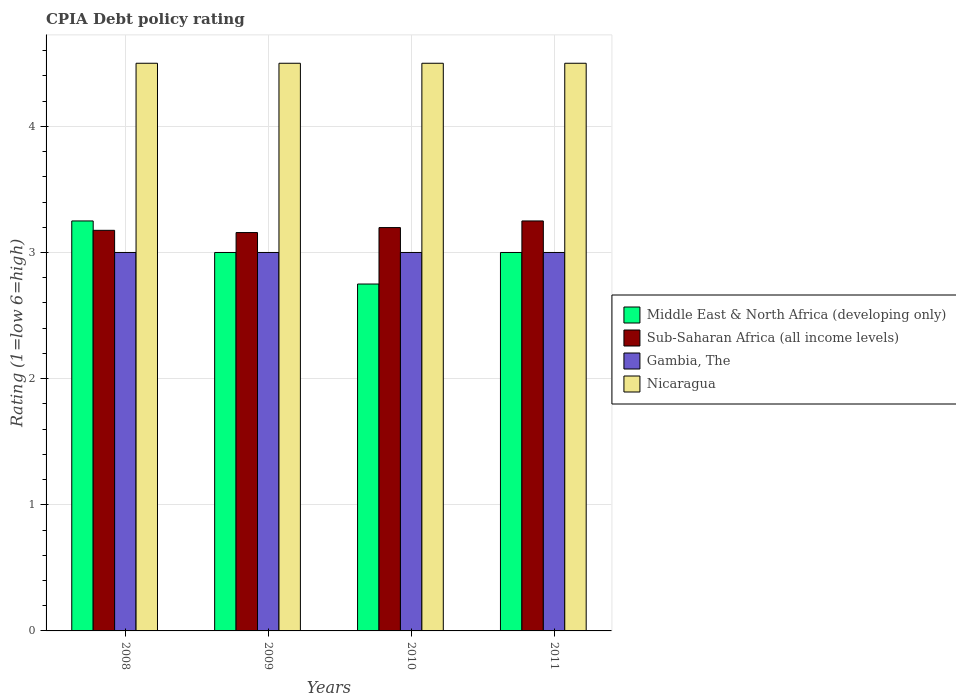Are the number of bars per tick equal to the number of legend labels?
Your answer should be compact. Yes. Are the number of bars on each tick of the X-axis equal?
Give a very brief answer. Yes. How many bars are there on the 1st tick from the right?
Your answer should be very brief. 4. What is the CPIA rating in Gambia, The in 2009?
Give a very brief answer. 3. Across all years, what is the maximum CPIA rating in Gambia, The?
Provide a short and direct response. 3. Across all years, what is the minimum CPIA rating in Middle East & North Africa (developing only)?
Offer a very short reply. 2.75. In which year was the CPIA rating in Gambia, The minimum?
Keep it short and to the point. 2008. What is the difference between the CPIA rating in Sub-Saharan Africa (all income levels) in 2010 and that in 2011?
Give a very brief answer. -0.05. What is the difference between the CPIA rating in Sub-Saharan Africa (all income levels) in 2011 and the CPIA rating in Gambia, The in 2010?
Your answer should be very brief. 0.25. What is the average CPIA rating in Nicaragua per year?
Provide a short and direct response. 4.5. In the year 2011, what is the difference between the CPIA rating in Middle East & North Africa (developing only) and CPIA rating in Nicaragua?
Provide a succinct answer. -1.5. What is the difference between the highest and the lowest CPIA rating in Sub-Saharan Africa (all income levels)?
Your response must be concise. 0.09. In how many years, is the CPIA rating in Nicaragua greater than the average CPIA rating in Nicaragua taken over all years?
Your answer should be very brief. 0. What does the 2nd bar from the left in 2010 represents?
Provide a short and direct response. Sub-Saharan Africa (all income levels). What does the 4th bar from the right in 2010 represents?
Your response must be concise. Middle East & North Africa (developing only). Is it the case that in every year, the sum of the CPIA rating in Middle East & North Africa (developing only) and CPIA rating in Nicaragua is greater than the CPIA rating in Sub-Saharan Africa (all income levels)?
Your answer should be compact. Yes. How many bars are there?
Provide a succinct answer. 16. What is the difference between two consecutive major ticks on the Y-axis?
Provide a succinct answer. 1. Where does the legend appear in the graph?
Make the answer very short. Center right. How are the legend labels stacked?
Your response must be concise. Vertical. What is the title of the graph?
Provide a short and direct response. CPIA Debt policy rating. What is the label or title of the X-axis?
Your answer should be compact. Years. What is the Rating (1=low 6=high) in Sub-Saharan Africa (all income levels) in 2008?
Provide a short and direct response. 3.18. What is the Rating (1=low 6=high) of Sub-Saharan Africa (all income levels) in 2009?
Your response must be concise. 3.16. What is the Rating (1=low 6=high) of Gambia, The in 2009?
Your answer should be very brief. 3. What is the Rating (1=low 6=high) in Nicaragua in 2009?
Ensure brevity in your answer.  4.5. What is the Rating (1=low 6=high) in Middle East & North Africa (developing only) in 2010?
Keep it short and to the point. 2.75. What is the Rating (1=low 6=high) of Sub-Saharan Africa (all income levels) in 2010?
Provide a short and direct response. 3.2. What is the Rating (1=low 6=high) of Middle East & North Africa (developing only) in 2011?
Provide a succinct answer. 3. What is the Rating (1=low 6=high) of Sub-Saharan Africa (all income levels) in 2011?
Your answer should be compact. 3.25. What is the Rating (1=low 6=high) in Nicaragua in 2011?
Your response must be concise. 4.5. Across all years, what is the maximum Rating (1=low 6=high) in Middle East & North Africa (developing only)?
Your response must be concise. 3.25. Across all years, what is the minimum Rating (1=low 6=high) of Middle East & North Africa (developing only)?
Your answer should be compact. 2.75. Across all years, what is the minimum Rating (1=low 6=high) of Sub-Saharan Africa (all income levels)?
Your response must be concise. 3.16. Across all years, what is the minimum Rating (1=low 6=high) of Gambia, The?
Make the answer very short. 3. Across all years, what is the minimum Rating (1=low 6=high) of Nicaragua?
Your answer should be very brief. 4.5. What is the total Rating (1=low 6=high) in Middle East & North Africa (developing only) in the graph?
Provide a short and direct response. 12. What is the total Rating (1=low 6=high) of Sub-Saharan Africa (all income levels) in the graph?
Give a very brief answer. 12.78. What is the total Rating (1=low 6=high) in Gambia, The in the graph?
Provide a short and direct response. 12. What is the total Rating (1=low 6=high) in Nicaragua in the graph?
Ensure brevity in your answer.  18. What is the difference between the Rating (1=low 6=high) in Sub-Saharan Africa (all income levels) in 2008 and that in 2009?
Your answer should be compact. 0.02. What is the difference between the Rating (1=low 6=high) of Gambia, The in 2008 and that in 2009?
Ensure brevity in your answer.  0. What is the difference between the Rating (1=low 6=high) in Nicaragua in 2008 and that in 2009?
Make the answer very short. 0. What is the difference between the Rating (1=low 6=high) in Middle East & North Africa (developing only) in 2008 and that in 2010?
Your answer should be very brief. 0.5. What is the difference between the Rating (1=low 6=high) of Sub-Saharan Africa (all income levels) in 2008 and that in 2010?
Offer a terse response. -0.02. What is the difference between the Rating (1=low 6=high) of Gambia, The in 2008 and that in 2010?
Your response must be concise. 0. What is the difference between the Rating (1=low 6=high) in Nicaragua in 2008 and that in 2010?
Keep it short and to the point. 0. What is the difference between the Rating (1=low 6=high) of Middle East & North Africa (developing only) in 2008 and that in 2011?
Ensure brevity in your answer.  0.25. What is the difference between the Rating (1=low 6=high) of Sub-Saharan Africa (all income levels) in 2008 and that in 2011?
Give a very brief answer. -0.07. What is the difference between the Rating (1=low 6=high) in Gambia, The in 2008 and that in 2011?
Offer a terse response. 0. What is the difference between the Rating (1=low 6=high) in Sub-Saharan Africa (all income levels) in 2009 and that in 2010?
Provide a succinct answer. -0.04. What is the difference between the Rating (1=low 6=high) in Gambia, The in 2009 and that in 2010?
Your answer should be compact. 0. What is the difference between the Rating (1=low 6=high) of Nicaragua in 2009 and that in 2010?
Give a very brief answer. 0. What is the difference between the Rating (1=low 6=high) in Middle East & North Africa (developing only) in 2009 and that in 2011?
Provide a succinct answer. 0. What is the difference between the Rating (1=low 6=high) of Sub-Saharan Africa (all income levels) in 2009 and that in 2011?
Provide a succinct answer. -0.09. What is the difference between the Rating (1=low 6=high) of Gambia, The in 2009 and that in 2011?
Provide a short and direct response. 0. What is the difference between the Rating (1=low 6=high) of Middle East & North Africa (developing only) in 2010 and that in 2011?
Make the answer very short. -0.25. What is the difference between the Rating (1=low 6=high) in Sub-Saharan Africa (all income levels) in 2010 and that in 2011?
Offer a very short reply. -0.05. What is the difference between the Rating (1=low 6=high) in Gambia, The in 2010 and that in 2011?
Offer a very short reply. 0. What is the difference between the Rating (1=low 6=high) of Middle East & North Africa (developing only) in 2008 and the Rating (1=low 6=high) of Sub-Saharan Africa (all income levels) in 2009?
Offer a terse response. 0.09. What is the difference between the Rating (1=low 6=high) of Middle East & North Africa (developing only) in 2008 and the Rating (1=low 6=high) of Gambia, The in 2009?
Your response must be concise. 0.25. What is the difference between the Rating (1=low 6=high) in Middle East & North Africa (developing only) in 2008 and the Rating (1=low 6=high) in Nicaragua in 2009?
Keep it short and to the point. -1.25. What is the difference between the Rating (1=low 6=high) in Sub-Saharan Africa (all income levels) in 2008 and the Rating (1=low 6=high) in Gambia, The in 2009?
Offer a very short reply. 0.18. What is the difference between the Rating (1=low 6=high) of Sub-Saharan Africa (all income levels) in 2008 and the Rating (1=low 6=high) of Nicaragua in 2009?
Make the answer very short. -1.32. What is the difference between the Rating (1=low 6=high) of Gambia, The in 2008 and the Rating (1=low 6=high) of Nicaragua in 2009?
Your answer should be compact. -1.5. What is the difference between the Rating (1=low 6=high) in Middle East & North Africa (developing only) in 2008 and the Rating (1=low 6=high) in Sub-Saharan Africa (all income levels) in 2010?
Offer a very short reply. 0.05. What is the difference between the Rating (1=low 6=high) in Middle East & North Africa (developing only) in 2008 and the Rating (1=low 6=high) in Nicaragua in 2010?
Offer a very short reply. -1.25. What is the difference between the Rating (1=low 6=high) of Sub-Saharan Africa (all income levels) in 2008 and the Rating (1=low 6=high) of Gambia, The in 2010?
Provide a succinct answer. 0.18. What is the difference between the Rating (1=low 6=high) of Sub-Saharan Africa (all income levels) in 2008 and the Rating (1=low 6=high) of Nicaragua in 2010?
Offer a very short reply. -1.32. What is the difference between the Rating (1=low 6=high) of Gambia, The in 2008 and the Rating (1=low 6=high) of Nicaragua in 2010?
Provide a short and direct response. -1.5. What is the difference between the Rating (1=low 6=high) in Middle East & North Africa (developing only) in 2008 and the Rating (1=low 6=high) in Sub-Saharan Africa (all income levels) in 2011?
Give a very brief answer. 0. What is the difference between the Rating (1=low 6=high) of Middle East & North Africa (developing only) in 2008 and the Rating (1=low 6=high) of Gambia, The in 2011?
Offer a very short reply. 0.25. What is the difference between the Rating (1=low 6=high) of Middle East & North Africa (developing only) in 2008 and the Rating (1=low 6=high) of Nicaragua in 2011?
Your response must be concise. -1.25. What is the difference between the Rating (1=low 6=high) of Sub-Saharan Africa (all income levels) in 2008 and the Rating (1=low 6=high) of Gambia, The in 2011?
Provide a succinct answer. 0.18. What is the difference between the Rating (1=low 6=high) of Sub-Saharan Africa (all income levels) in 2008 and the Rating (1=low 6=high) of Nicaragua in 2011?
Give a very brief answer. -1.32. What is the difference between the Rating (1=low 6=high) of Middle East & North Africa (developing only) in 2009 and the Rating (1=low 6=high) of Sub-Saharan Africa (all income levels) in 2010?
Provide a succinct answer. -0.2. What is the difference between the Rating (1=low 6=high) in Sub-Saharan Africa (all income levels) in 2009 and the Rating (1=low 6=high) in Gambia, The in 2010?
Offer a very short reply. 0.16. What is the difference between the Rating (1=low 6=high) in Sub-Saharan Africa (all income levels) in 2009 and the Rating (1=low 6=high) in Nicaragua in 2010?
Make the answer very short. -1.34. What is the difference between the Rating (1=low 6=high) of Middle East & North Africa (developing only) in 2009 and the Rating (1=low 6=high) of Gambia, The in 2011?
Provide a succinct answer. 0. What is the difference between the Rating (1=low 6=high) of Middle East & North Africa (developing only) in 2009 and the Rating (1=low 6=high) of Nicaragua in 2011?
Make the answer very short. -1.5. What is the difference between the Rating (1=low 6=high) in Sub-Saharan Africa (all income levels) in 2009 and the Rating (1=low 6=high) in Gambia, The in 2011?
Ensure brevity in your answer.  0.16. What is the difference between the Rating (1=low 6=high) of Sub-Saharan Africa (all income levels) in 2009 and the Rating (1=low 6=high) of Nicaragua in 2011?
Offer a terse response. -1.34. What is the difference between the Rating (1=low 6=high) of Middle East & North Africa (developing only) in 2010 and the Rating (1=low 6=high) of Sub-Saharan Africa (all income levels) in 2011?
Ensure brevity in your answer.  -0.5. What is the difference between the Rating (1=low 6=high) of Middle East & North Africa (developing only) in 2010 and the Rating (1=low 6=high) of Gambia, The in 2011?
Your response must be concise. -0.25. What is the difference between the Rating (1=low 6=high) of Middle East & North Africa (developing only) in 2010 and the Rating (1=low 6=high) of Nicaragua in 2011?
Your answer should be compact. -1.75. What is the difference between the Rating (1=low 6=high) in Sub-Saharan Africa (all income levels) in 2010 and the Rating (1=low 6=high) in Gambia, The in 2011?
Keep it short and to the point. 0.2. What is the difference between the Rating (1=low 6=high) in Sub-Saharan Africa (all income levels) in 2010 and the Rating (1=low 6=high) in Nicaragua in 2011?
Your answer should be very brief. -1.3. What is the average Rating (1=low 6=high) of Sub-Saharan Africa (all income levels) per year?
Offer a very short reply. 3.2. What is the average Rating (1=low 6=high) in Gambia, The per year?
Provide a short and direct response. 3. What is the average Rating (1=low 6=high) in Nicaragua per year?
Offer a terse response. 4.5. In the year 2008, what is the difference between the Rating (1=low 6=high) of Middle East & North Africa (developing only) and Rating (1=low 6=high) of Sub-Saharan Africa (all income levels)?
Give a very brief answer. 0.07. In the year 2008, what is the difference between the Rating (1=low 6=high) in Middle East & North Africa (developing only) and Rating (1=low 6=high) in Gambia, The?
Provide a succinct answer. 0.25. In the year 2008, what is the difference between the Rating (1=low 6=high) in Middle East & North Africa (developing only) and Rating (1=low 6=high) in Nicaragua?
Give a very brief answer. -1.25. In the year 2008, what is the difference between the Rating (1=low 6=high) of Sub-Saharan Africa (all income levels) and Rating (1=low 6=high) of Gambia, The?
Your answer should be compact. 0.18. In the year 2008, what is the difference between the Rating (1=low 6=high) of Sub-Saharan Africa (all income levels) and Rating (1=low 6=high) of Nicaragua?
Provide a short and direct response. -1.32. In the year 2008, what is the difference between the Rating (1=low 6=high) of Gambia, The and Rating (1=low 6=high) of Nicaragua?
Your answer should be very brief. -1.5. In the year 2009, what is the difference between the Rating (1=low 6=high) of Middle East & North Africa (developing only) and Rating (1=low 6=high) of Sub-Saharan Africa (all income levels)?
Your response must be concise. -0.16. In the year 2009, what is the difference between the Rating (1=low 6=high) of Middle East & North Africa (developing only) and Rating (1=low 6=high) of Nicaragua?
Provide a succinct answer. -1.5. In the year 2009, what is the difference between the Rating (1=low 6=high) of Sub-Saharan Africa (all income levels) and Rating (1=low 6=high) of Gambia, The?
Make the answer very short. 0.16. In the year 2009, what is the difference between the Rating (1=low 6=high) of Sub-Saharan Africa (all income levels) and Rating (1=low 6=high) of Nicaragua?
Keep it short and to the point. -1.34. In the year 2009, what is the difference between the Rating (1=low 6=high) of Gambia, The and Rating (1=low 6=high) of Nicaragua?
Give a very brief answer. -1.5. In the year 2010, what is the difference between the Rating (1=low 6=high) in Middle East & North Africa (developing only) and Rating (1=low 6=high) in Sub-Saharan Africa (all income levels)?
Your response must be concise. -0.45. In the year 2010, what is the difference between the Rating (1=low 6=high) of Middle East & North Africa (developing only) and Rating (1=low 6=high) of Gambia, The?
Offer a terse response. -0.25. In the year 2010, what is the difference between the Rating (1=low 6=high) of Middle East & North Africa (developing only) and Rating (1=low 6=high) of Nicaragua?
Your response must be concise. -1.75. In the year 2010, what is the difference between the Rating (1=low 6=high) in Sub-Saharan Africa (all income levels) and Rating (1=low 6=high) in Gambia, The?
Make the answer very short. 0.2. In the year 2010, what is the difference between the Rating (1=low 6=high) in Sub-Saharan Africa (all income levels) and Rating (1=low 6=high) in Nicaragua?
Provide a succinct answer. -1.3. In the year 2011, what is the difference between the Rating (1=low 6=high) in Middle East & North Africa (developing only) and Rating (1=low 6=high) in Sub-Saharan Africa (all income levels)?
Your answer should be compact. -0.25. In the year 2011, what is the difference between the Rating (1=low 6=high) of Middle East & North Africa (developing only) and Rating (1=low 6=high) of Nicaragua?
Provide a short and direct response. -1.5. In the year 2011, what is the difference between the Rating (1=low 6=high) of Sub-Saharan Africa (all income levels) and Rating (1=low 6=high) of Nicaragua?
Offer a very short reply. -1.25. What is the ratio of the Rating (1=low 6=high) in Sub-Saharan Africa (all income levels) in 2008 to that in 2009?
Your answer should be very brief. 1.01. What is the ratio of the Rating (1=low 6=high) of Nicaragua in 2008 to that in 2009?
Keep it short and to the point. 1. What is the ratio of the Rating (1=low 6=high) of Middle East & North Africa (developing only) in 2008 to that in 2010?
Your answer should be very brief. 1.18. What is the ratio of the Rating (1=low 6=high) in Sub-Saharan Africa (all income levels) in 2008 to that in 2010?
Ensure brevity in your answer.  0.99. What is the ratio of the Rating (1=low 6=high) in Gambia, The in 2008 to that in 2010?
Make the answer very short. 1. What is the ratio of the Rating (1=low 6=high) in Sub-Saharan Africa (all income levels) in 2008 to that in 2011?
Give a very brief answer. 0.98. What is the ratio of the Rating (1=low 6=high) of Gambia, The in 2008 to that in 2011?
Your response must be concise. 1. What is the ratio of the Rating (1=low 6=high) of Nicaragua in 2008 to that in 2011?
Provide a short and direct response. 1. What is the ratio of the Rating (1=low 6=high) in Middle East & North Africa (developing only) in 2009 to that in 2010?
Provide a short and direct response. 1.09. What is the ratio of the Rating (1=low 6=high) in Middle East & North Africa (developing only) in 2009 to that in 2011?
Your response must be concise. 1. What is the ratio of the Rating (1=low 6=high) in Sub-Saharan Africa (all income levels) in 2009 to that in 2011?
Your answer should be very brief. 0.97. What is the ratio of the Rating (1=low 6=high) in Nicaragua in 2009 to that in 2011?
Offer a terse response. 1. What is the ratio of the Rating (1=low 6=high) of Sub-Saharan Africa (all income levels) in 2010 to that in 2011?
Your answer should be compact. 0.98. What is the ratio of the Rating (1=low 6=high) of Nicaragua in 2010 to that in 2011?
Provide a succinct answer. 1. What is the difference between the highest and the second highest Rating (1=low 6=high) of Middle East & North Africa (developing only)?
Your response must be concise. 0.25. What is the difference between the highest and the second highest Rating (1=low 6=high) of Sub-Saharan Africa (all income levels)?
Your response must be concise. 0.05. What is the difference between the highest and the second highest Rating (1=low 6=high) in Nicaragua?
Offer a terse response. 0. What is the difference between the highest and the lowest Rating (1=low 6=high) in Middle East & North Africa (developing only)?
Make the answer very short. 0.5. What is the difference between the highest and the lowest Rating (1=low 6=high) in Sub-Saharan Africa (all income levels)?
Keep it short and to the point. 0.09. What is the difference between the highest and the lowest Rating (1=low 6=high) of Gambia, The?
Provide a short and direct response. 0. 